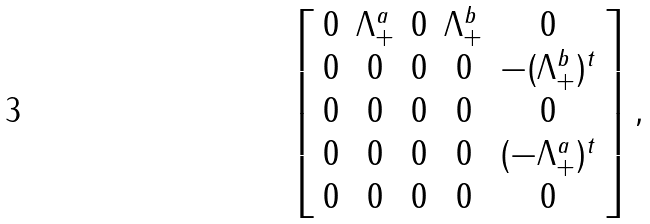Convert formula to latex. <formula><loc_0><loc_0><loc_500><loc_500>\left [ \begin{array} { c c c c c } 0 & \Lambda _ { + } ^ { a } & 0 & \Lambda _ { + } ^ { b } & 0 \\ 0 & 0 & 0 & 0 & - ( \Lambda _ { + } ^ { b } ) ^ { t } \\ 0 & 0 & 0 & 0 & 0 \\ 0 & 0 & 0 & 0 & ( - \Lambda _ { + } ^ { a } ) ^ { t } \\ 0 & 0 & 0 & 0 & 0 \end{array} \right ] ,</formula> 